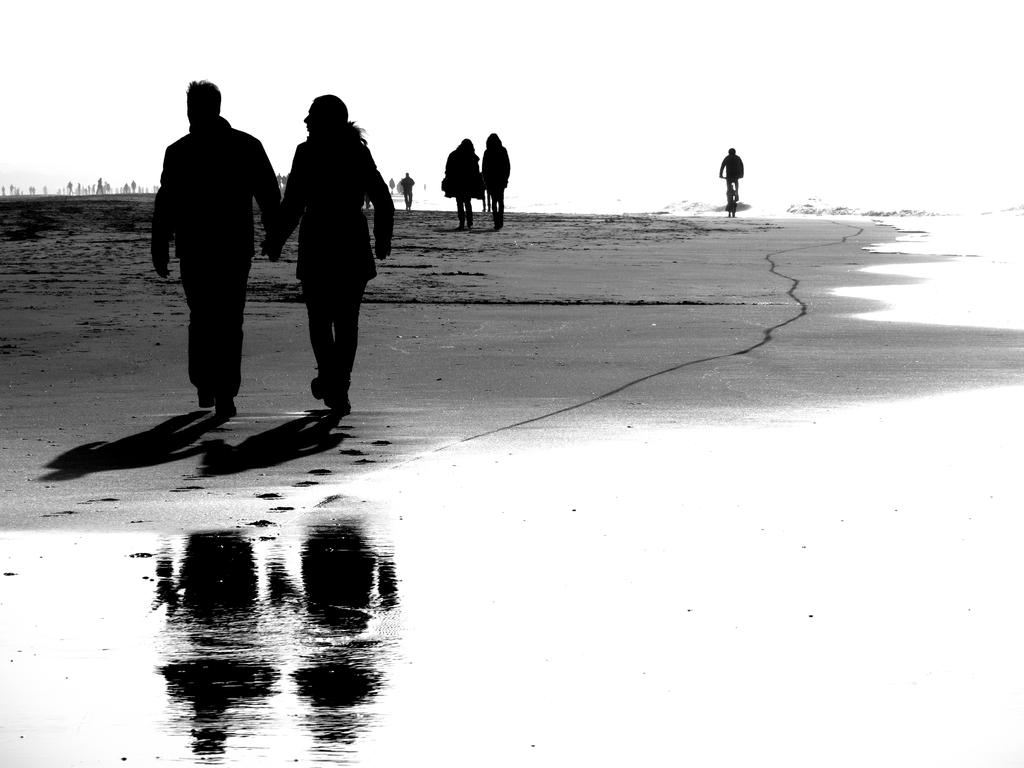What are the persons in the image doing? The persons in the image are walking. What can be seen on the right side of the image? There is water visible on the right side of the image. What type of mitten can be seen on the rail in the image? There is no rail present in the image, and therefore no mitten or any other object can be seen on it. 